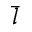Convert formula to latex. <formula><loc_0><loc_0><loc_500><loc_500>\bar { l }</formula> 